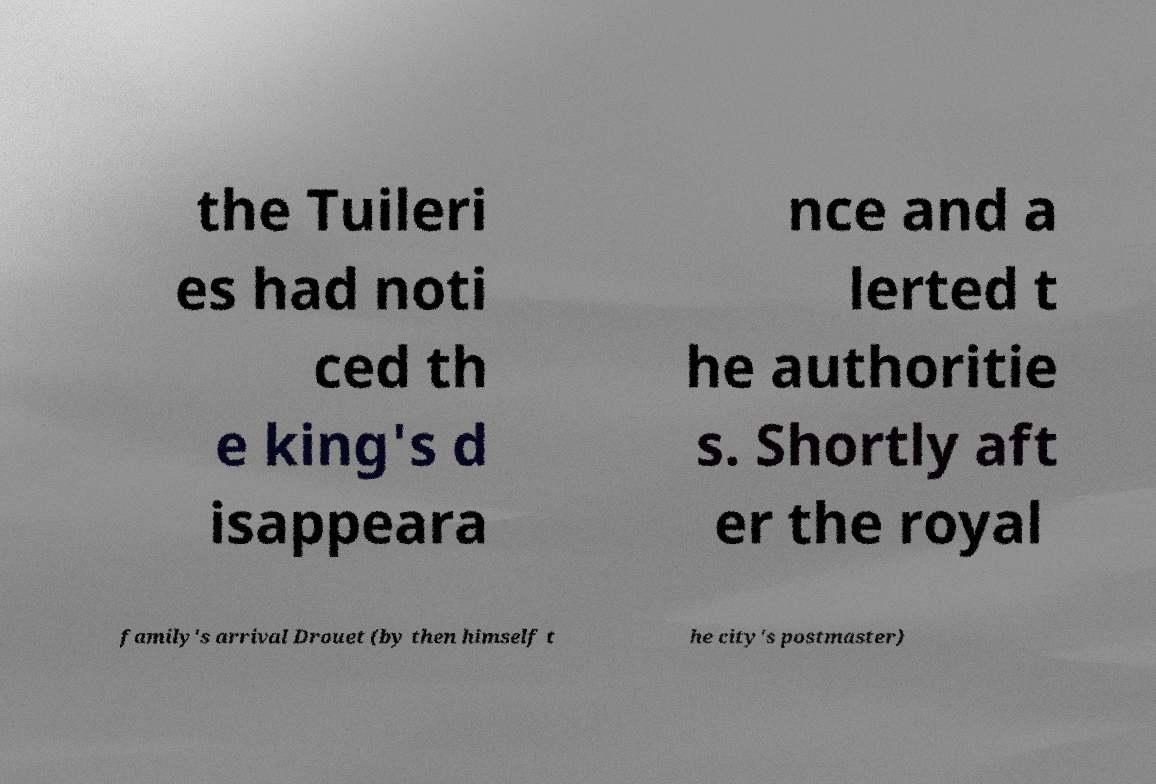I need the written content from this picture converted into text. Can you do that? the Tuileri es had noti ced th e king's d isappeara nce and a lerted t he authoritie s. Shortly aft er the royal family's arrival Drouet (by then himself t he city's postmaster) 